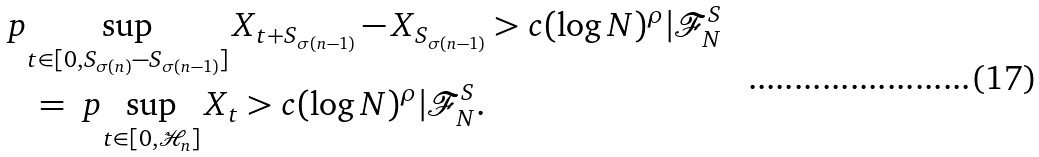Convert formula to latex. <formula><loc_0><loc_0><loc_500><loc_500>& \ p { \sup _ { t \in [ 0 , S _ { \sigma ( n ) } - S _ { \sigma ( n - 1 ) } ] } X _ { t + S _ { \sigma ( n - 1 ) } } - X _ { S _ { \sigma ( n - 1 ) } } > c ( \log N ) ^ { \rho } | \mathcal { F } _ { N } ^ { S } } \\ & \quad = \ p { \sup _ { t \in [ 0 , \mathcal { H } _ { n } ] } X _ { t } > c ( \log N ) ^ { \rho } | \mathcal { F } _ { N } ^ { S } } .</formula> 